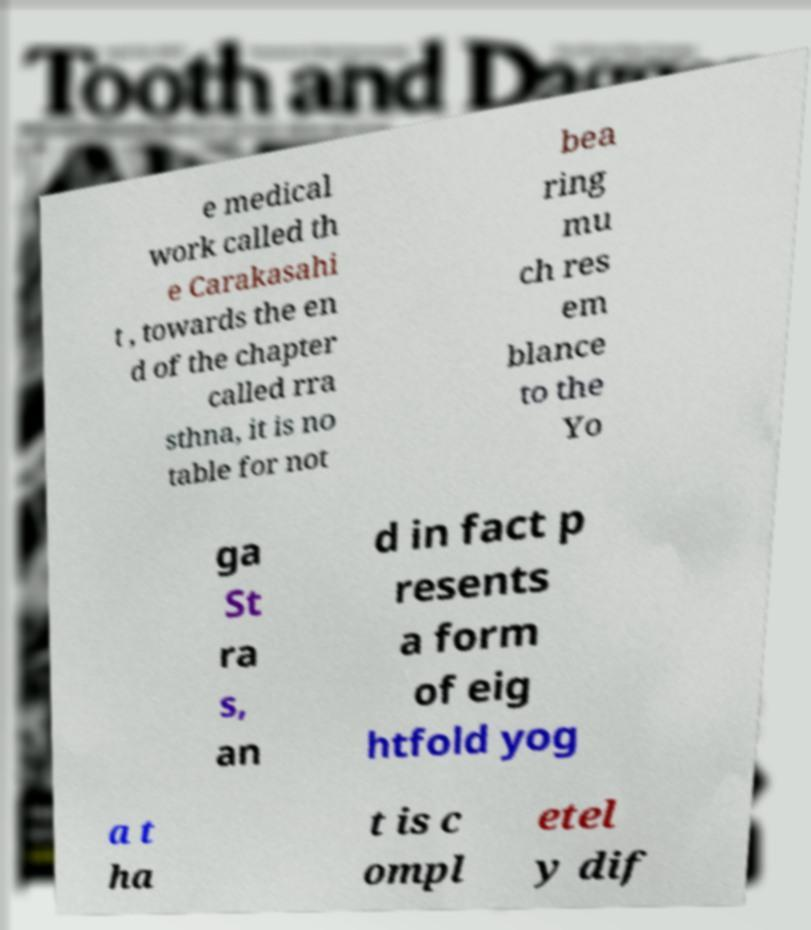Can you read and provide the text displayed in the image?This photo seems to have some interesting text. Can you extract and type it out for me? e medical work called th e Carakasahi t , towards the en d of the chapter called rra sthna, it is no table for not bea ring mu ch res em blance to the Yo ga St ra s, an d in fact p resents a form of eig htfold yog a t ha t is c ompl etel y dif 